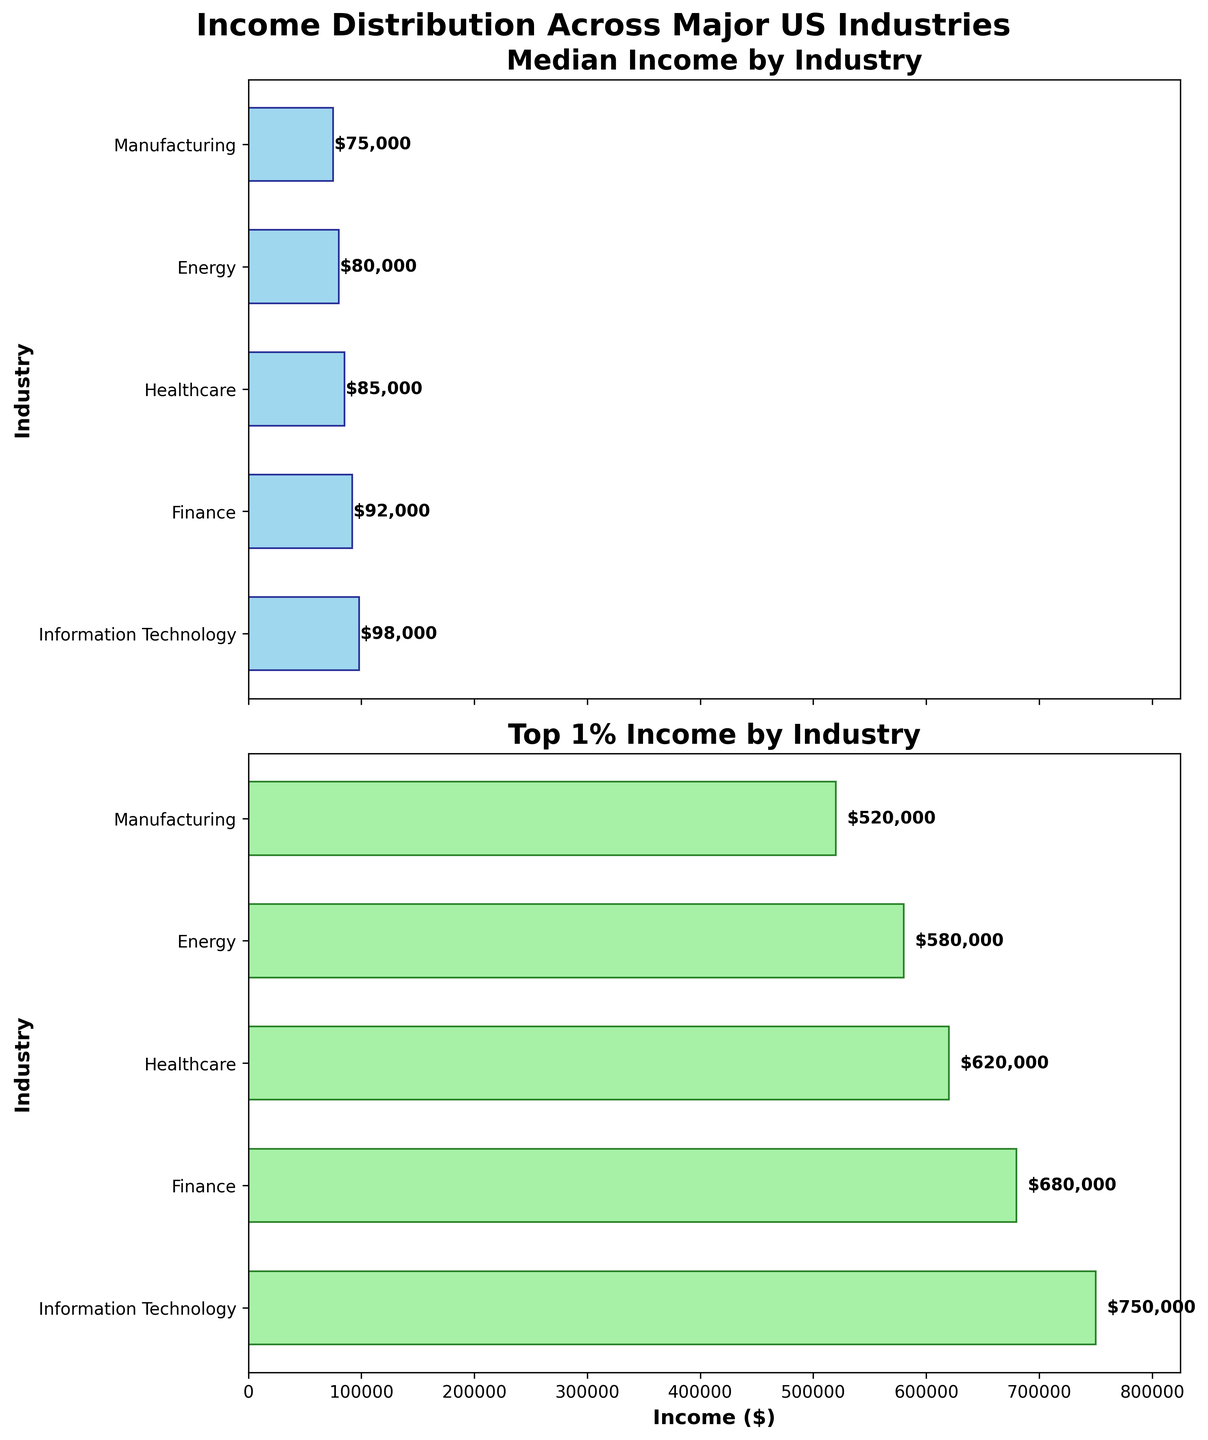Which industry has the highest median income? The first subplot shows the median incomes by industry. By looking at the height of each bar, Information Technology has the highest median income bar.
Answer: Information Technology What is the dollar value of the top 1% income in the Finance industry? Refer to the second subplot for top 1% income by industry. The bar corresponding to Finance shows a value, and the text near the end of the bar shows $680,000.
Answer: $680,000 Compare the median income in Healthcare to that in Energy. Which is higher? Look at the bars in the first subplot for Healthcare and Energy. Healthcare's bar is higher and has a value of $85,000 while Energy's bar shows $80,000.
Answer: Healthcare How much more is the top 1% income in Information Technology compared to Manufacturing? The second subplot shows the top 1% income bars: $750,000 (Information Technology) and $520,000 (Manufacturing). Calculate the difference: 750,000 - 520,000 = 230,000.
Answer: $230,000 What are the titles of the two subplots? The titles are displayed above each subplot. The first one reads 'Median Income by Industry' and the second one reads 'Top 1% Income by Industry'.
Answer: Median Income by Industry, Top 1% Income by Industry Which sector shows the smallest difference between median income and top 1% income? Calculate the difference for each industry using the bars: 
- Information Technology: 750,000 - 98,000 = 652,000
- Finance: 680,000 - 92,000 = 588,000
- Healthcare: 620,000 - 85,000 = 535,000
- Energy: 580,000 - 80,000 = 500,000
- Manufacturing: 520,000 - 75,000 = 445,000
Manufacturing has the smallest difference.
Answer: Manufacturing What's the average median income across all industries shown? Add the median incomes: 
98,000 (Information Technology) + 92,000 (Finance) + 85,000 (Healthcare) + 80,000 (Energy) + 75,000 (Manufacturing) = 430,000.
Divide by the number of industries: 430,000 / 5 = 86,000.
Answer: $86,000 What industry exhibits the highest disparity between median and top 1% income? Review the differences calculated before:
- Information Technology: 652,000
- Finance: 588,000
- Healthcare: 535,000
- Energy: 500,000
- Manufacturing: 445,000
The highest disparity is in Information Technology.
Answer: Information Technology 